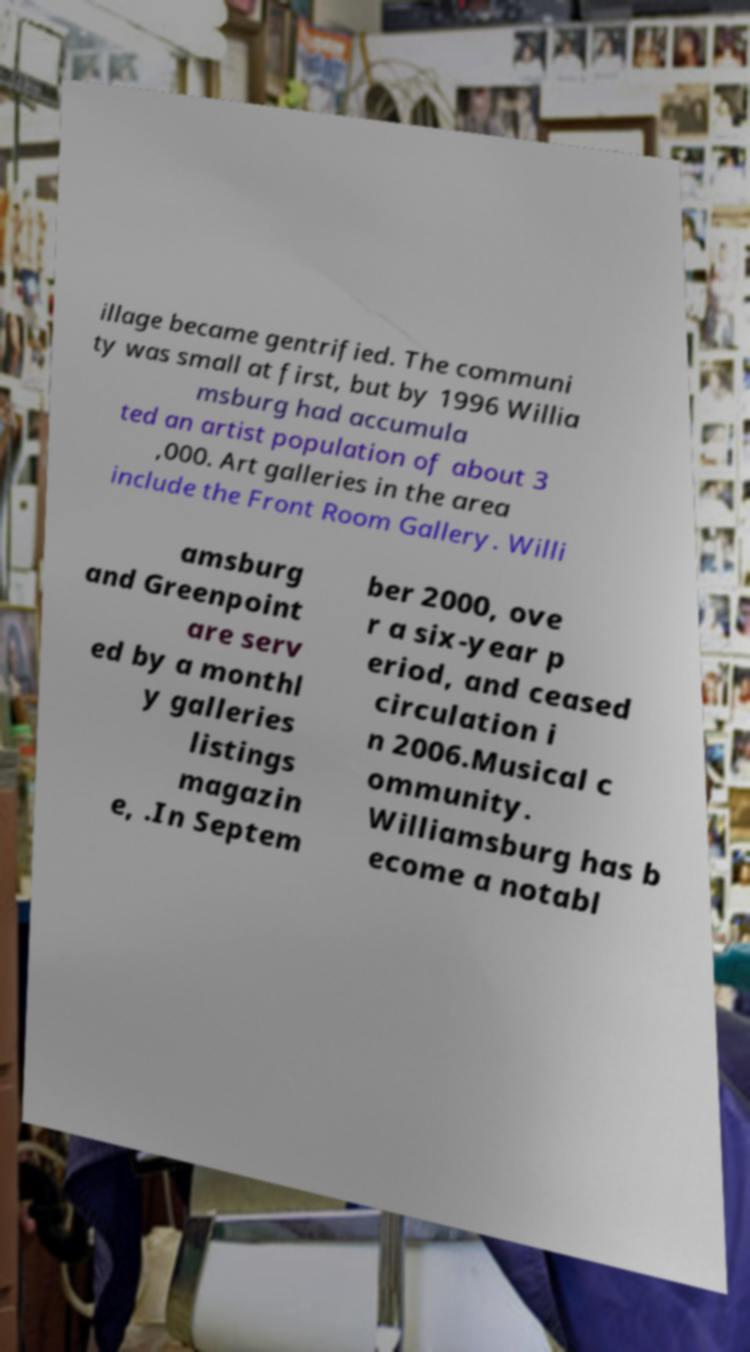Could you assist in decoding the text presented in this image and type it out clearly? illage became gentrified. The communi ty was small at first, but by 1996 Willia msburg had accumula ted an artist population of about 3 ,000. Art galleries in the area include the Front Room Gallery. Willi amsburg and Greenpoint are serv ed by a monthl y galleries listings magazin e, .In Septem ber 2000, ove r a six-year p eriod, and ceased circulation i n 2006.Musical c ommunity. Williamsburg has b ecome a notabl 